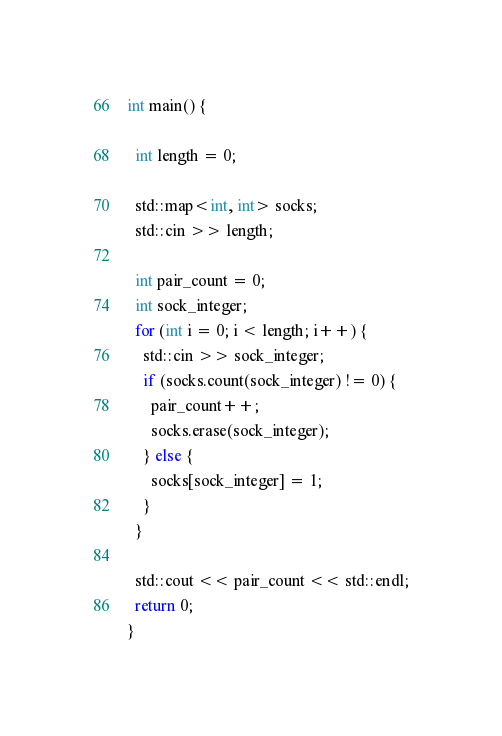Convert code to text. <code><loc_0><loc_0><loc_500><loc_500><_C++_>int main() {

  int length = 0;

  std::map<int, int> socks;
  std::cin >> length;

  int pair_count = 0;
  int sock_integer;
  for (int i = 0; i < length; i++) {
    std::cin >> sock_integer;
    if (socks.count(sock_integer) != 0) {
      pair_count++;
      socks.erase(sock_integer);
    } else {
      socks[sock_integer] = 1;
    }
  }

  std::cout << pair_count << std::endl;
  return 0;
}
</code> 